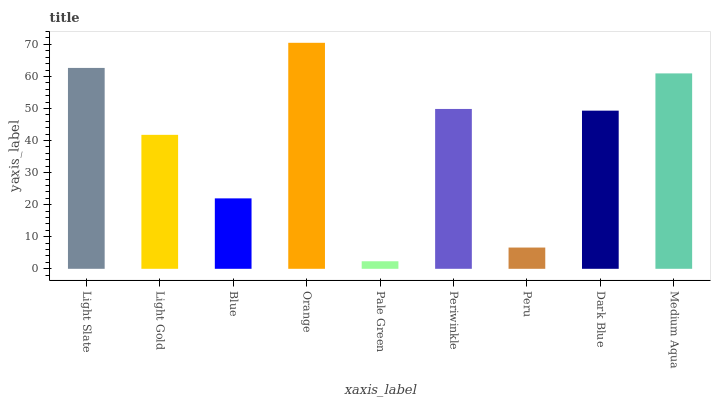Is Pale Green the minimum?
Answer yes or no. Yes. Is Orange the maximum?
Answer yes or no. Yes. Is Light Gold the minimum?
Answer yes or no. No. Is Light Gold the maximum?
Answer yes or no. No. Is Light Slate greater than Light Gold?
Answer yes or no. Yes. Is Light Gold less than Light Slate?
Answer yes or no. Yes. Is Light Gold greater than Light Slate?
Answer yes or no. No. Is Light Slate less than Light Gold?
Answer yes or no. No. Is Dark Blue the high median?
Answer yes or no. Yes. Is Dark Blue the low median?
Answer yes or no. Yes. Is Blue the high median?
Answer yes or no. No. Is Pale Green the low median?
Answer yes or no. No. 